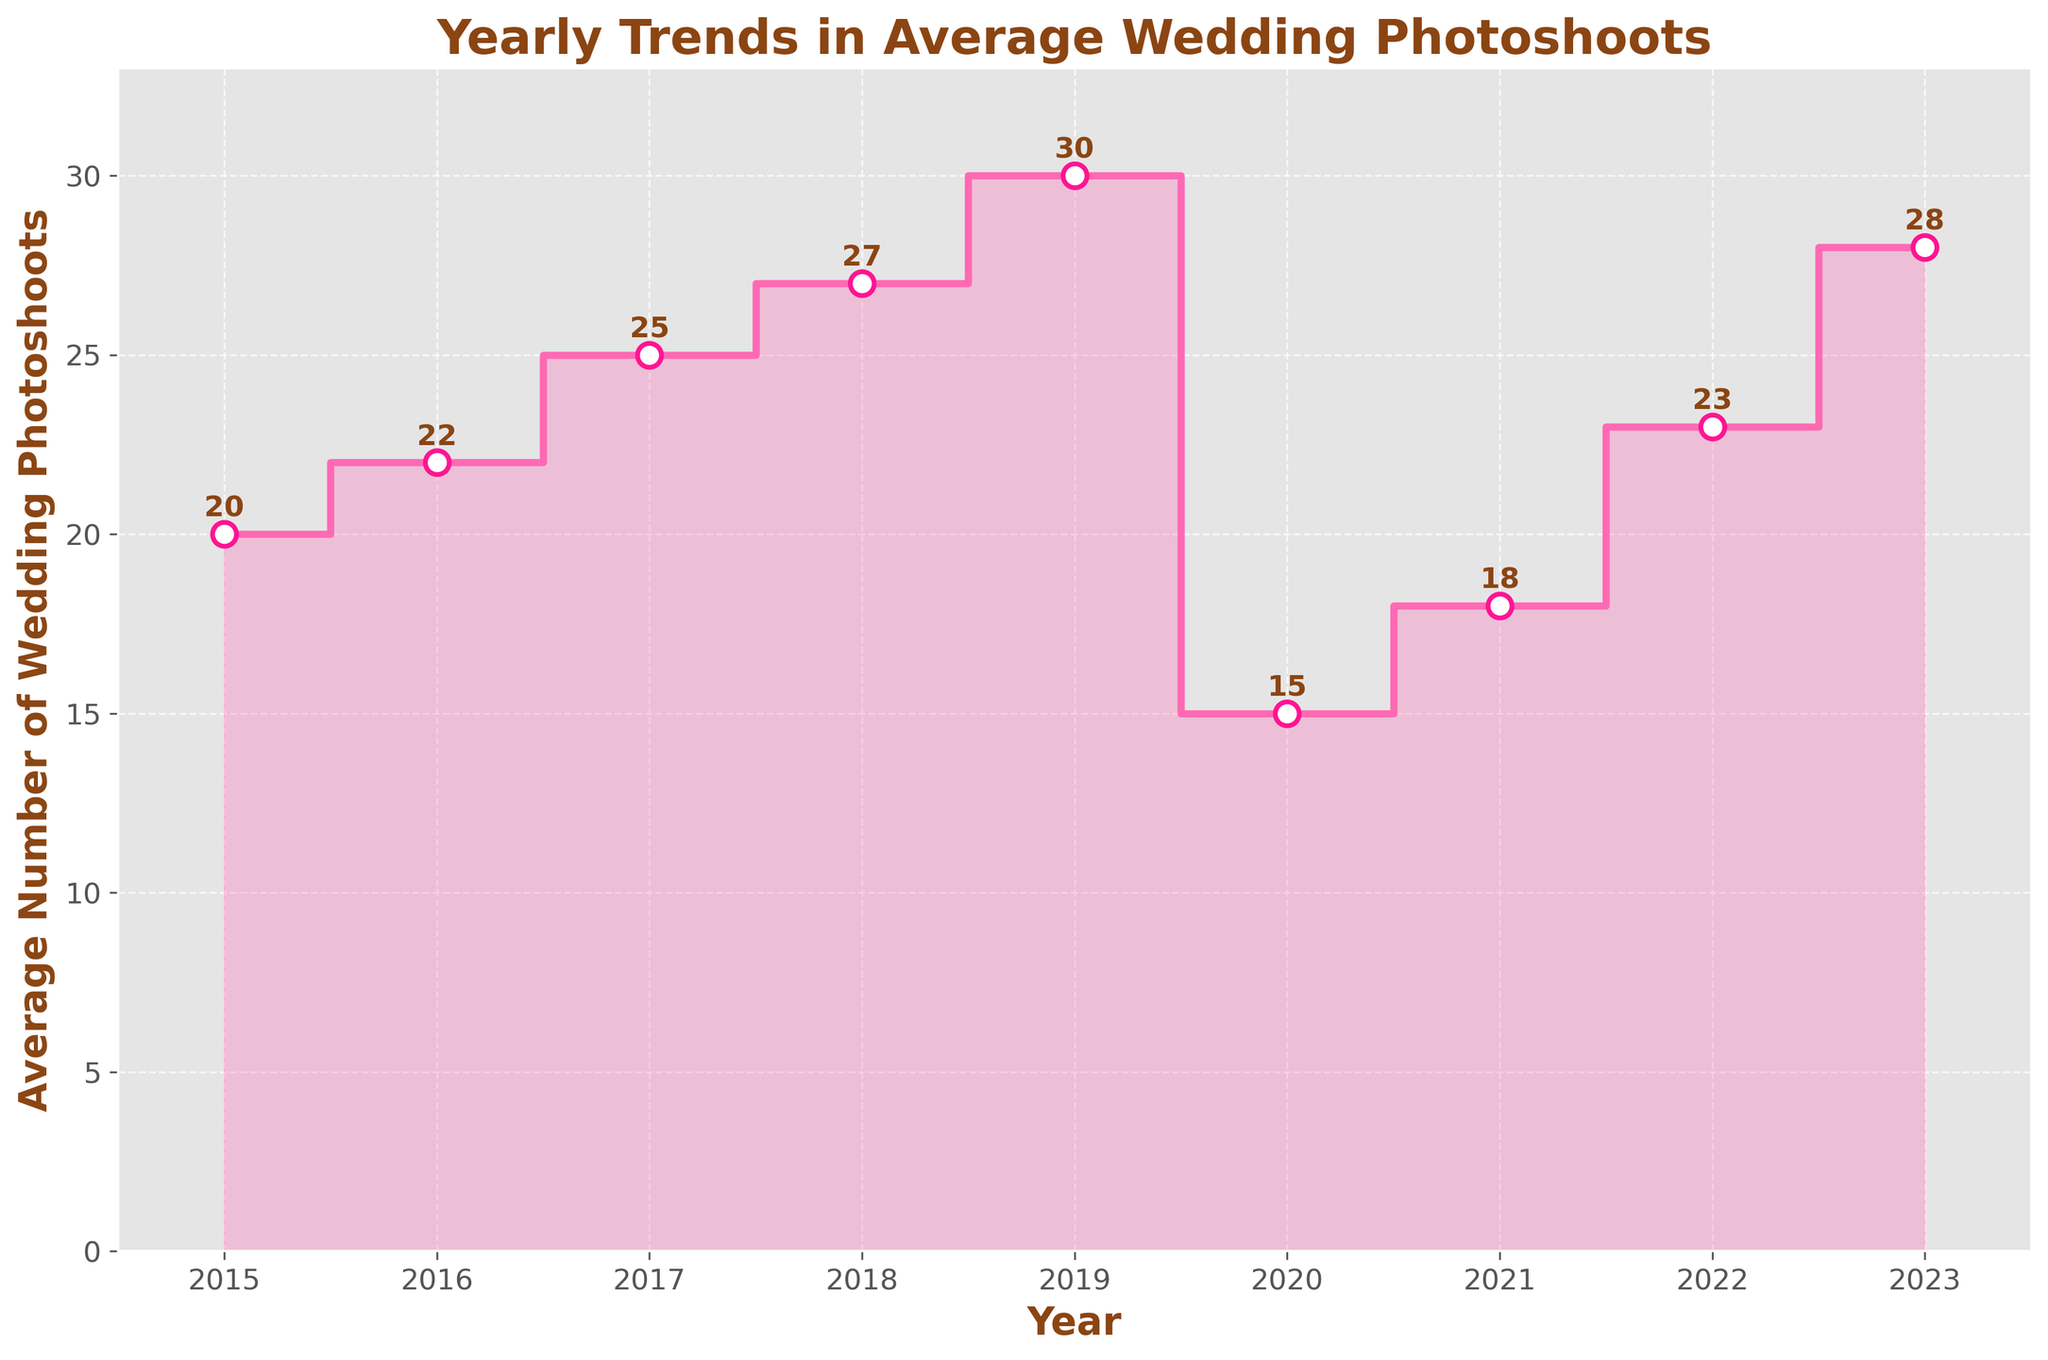What is the title of the plot? The title is located at the top of the plot and it clearly states the overall subject of the data.
Answer: Yearly Trends in Average Wedding Photoshoots How many data points are there in the plot? Count the number of markers or labeled years along the x-axis to determine the number of data points.
Answer: 9 Which year had the lowest average number of wedding photoshoots? Identify the year associated with the minimum data point along the y-axis. The data point will have the smallest value among all.
Answer: 2020 What is the range of average wedding photoshoots from 2015 to 2023? Subtract the minimum value from the maximum value of average wedding photoshoots within the given years.
Answer: 30 - 15 = 15 How much did the average number of wedding photoshoots decrease from 2019 to 2020? Subtract the value of average wedding photoshoots in 2020 from that in 2019.
Answer: 30 - 15 = 15 Which year saw the largest increase in average wedding photoshoots compared to the previous year? Calculate the difference in average wedding photoshoots between consecutive years and identify the maximum increase.
Answer: 2022 to 2023 Was there any year where the average number of wedding photoshoots did not change compared to the previous year? Analyze the differences between consecutive years to check for any zero differences.
Answer: No What is the overall trend in average wedding photoshoots from 2015 to 2023? Analyze the slope and direction of the line formed by connecting the average wedding photoshoots across years.
Answer: Increasing How many years had more than 25 average wedding photoshoots? Count how many years' average wedding photoshoots values exceed 25.
Answer: 4 What's the average number of wedding photoshoots across all the years? Sum all the average wedding photoshoots from 2015 to 2023 and divide by the number of years.
Answer: (20 + 22 + 25 + 27 + 30 + 15 + 18 + 23 + 28) / 9 = 23.11 